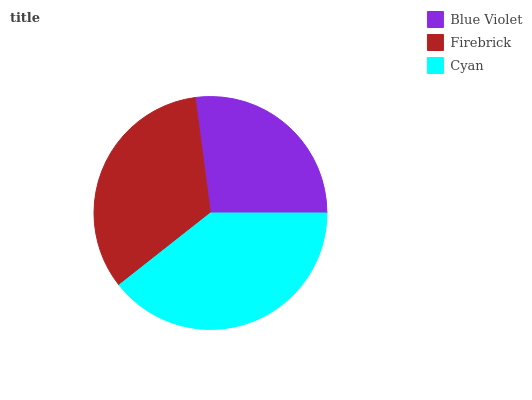Is Blue Violet the minimum?
Answer yes or no. Yes. Is Cyan the maximum?
Answer yes or no. Yes. Is Firebrick the minimum?
Answer yes or no. No. Is Firebrick the maximum?
Answer yes or no. No. Is Firebrick greater than Blue Violet?
Answer yes or no. Yes. Is Blue Violet less than Firebrick?
Answer yes or no. Yes. Is Blue Violet greater than Firebrick?
Answer yes or no. No. Is Firebrick less than Blue Violet?
Answer yes or no. No. Is Firebrick the high median?
Answer yes or no. Yes. Is Firebrick the low median?
Answer yes or no. Yes. Is Blue Violet the high median?
Answer yes or no. No. Is Cyan the low median?
Answer yes or no. No. 